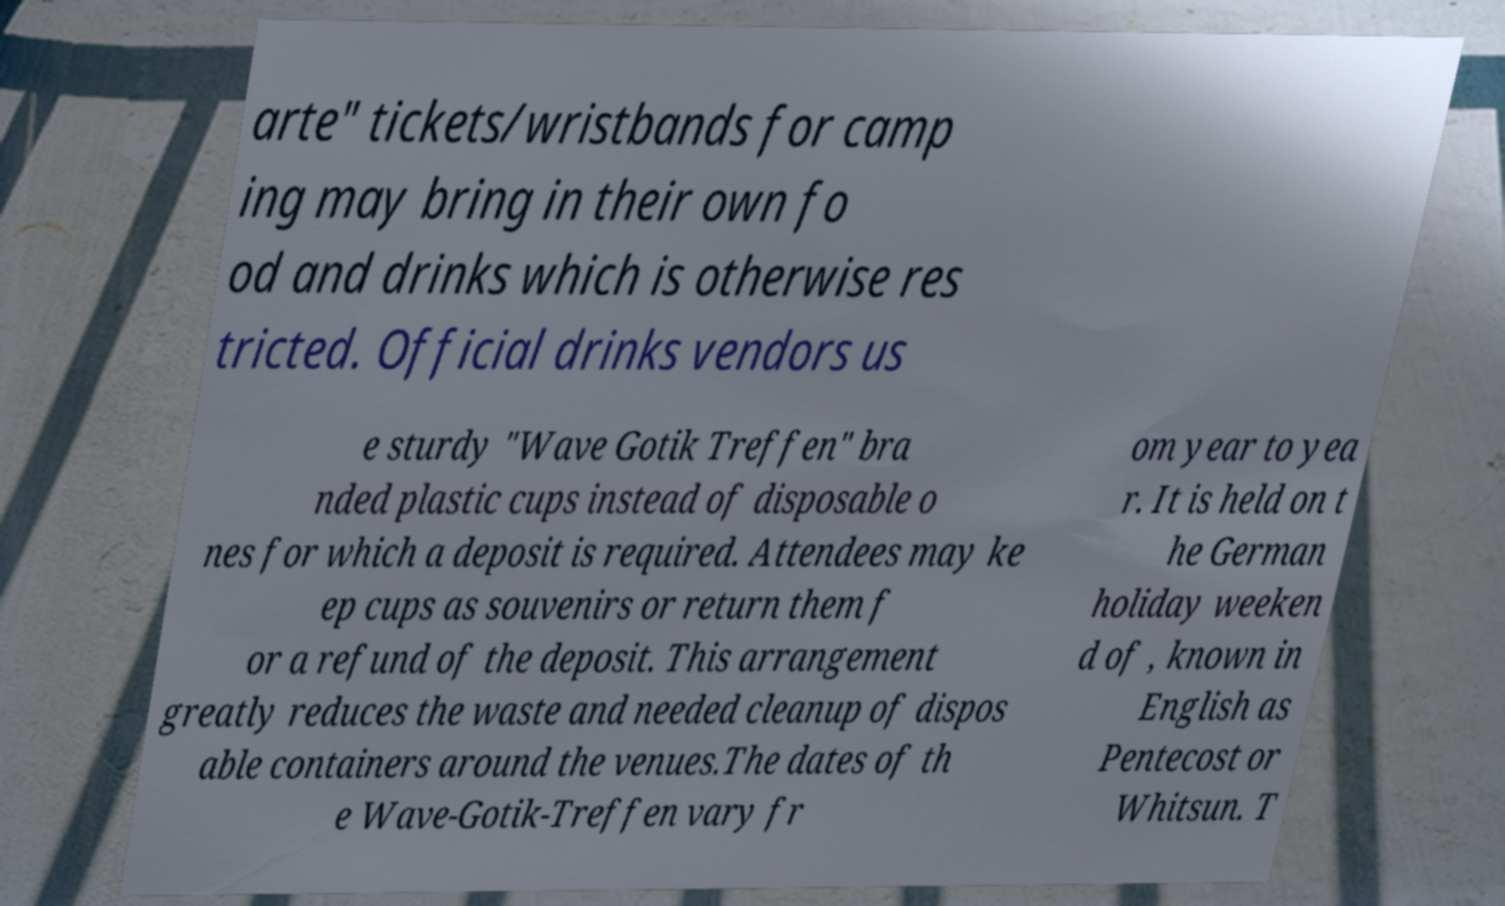Could you extract and type out the text from this image? arte" tickets/wristbands for camp ing may bring in their own fo od and drinks which is otherwise res tricted. Official drinks vendors us e sturdy "Wave Gotik Treffen" bra nded plastic cups instead of disposable o nes for which a deposit is required. Attendees may ke ep cups as souvenirs or return them f or a refund of the deposit. This arrangement greatly reduces the waste and needed cleanup of dispos able containers around the venues.The dates of th e Wave-Gotik-Treffen vary fr om year to yea r. It is held on t he German holiday weeken d of , known in English as Pentecost or Whitsun. T 